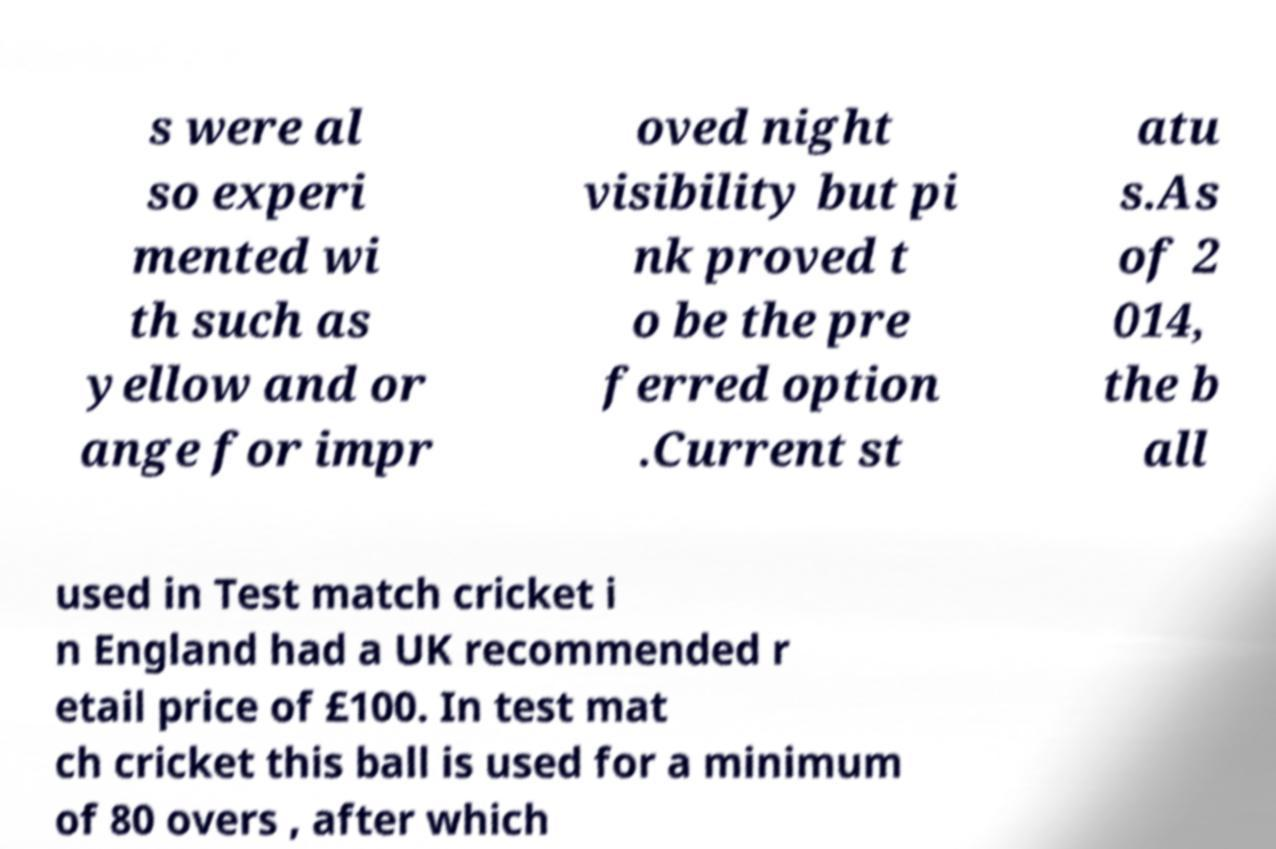Please identify and transcribe the text found in this image. s were al so experi mented wi th such as yellow and or ange for impr oved night visibility but pi nk proved t o be the pre ferred option .Current st atu s.As of 2 014, the b all used in Test match cricket i n England had a UK recommended r etail price of £100. In test mat ch cricket this ball is used for a minimum of 80 overs , after which 